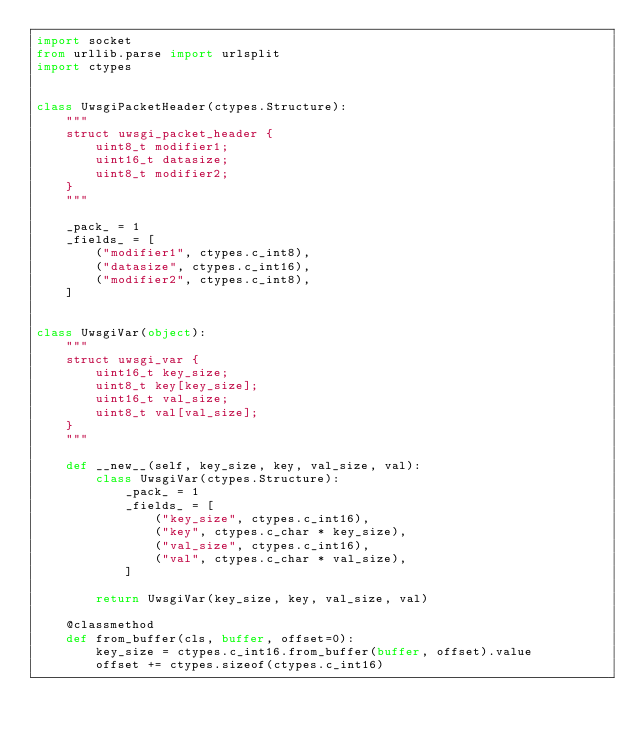<code> <loc_0><loc_0><loc_500><loc_500><_Python_>import socket
from urllib.parse import urlsplit
import ctypes


class UwsgiPacketHeader(ctypes.Structure):
    """
    struct uwsgi_packet_header {
        uint8_t modifier1;
        uint16_t datasize;
        uint8_t modifier2;
    }
    """

    _pack_ = 1
    _fields_ = [
        ("modifier1", ctypes.c_int8),
        ("datasize", ctypes.c_int16),
        ("modifier2", ctypes.c_int8),
    ]


class UwsgiVar(object):
    """
    struct uwsgi_var {
        uint16_t key_size;
        uint8_t key[key_size];
        uint16_t val_size;
        uint8_t val[val_size];
    }
    """

    def __new__(self, key_size, key, val_size, val):
        class UwsgiVar(ctypes.Structure):
            _pack_ = 1
            _fields_ = [
                ("key_size", ctypes.c_int16),
                ("key", ctypes.c_char * key_size),
                ("val_size", ctypes.c_int16),
                ("val", ctypes.c_char * val_size),
            ]

        return UwsgiVar(key_size, key, val_size, val)

    @classmethod
    def from_buffer(cls, buffer, offset=0):
        key_size = ctypes.c_int16.from_buffer(buffer, offset).value
        offset += ctypes.sizeof(ctypes.c_int16)</code> 